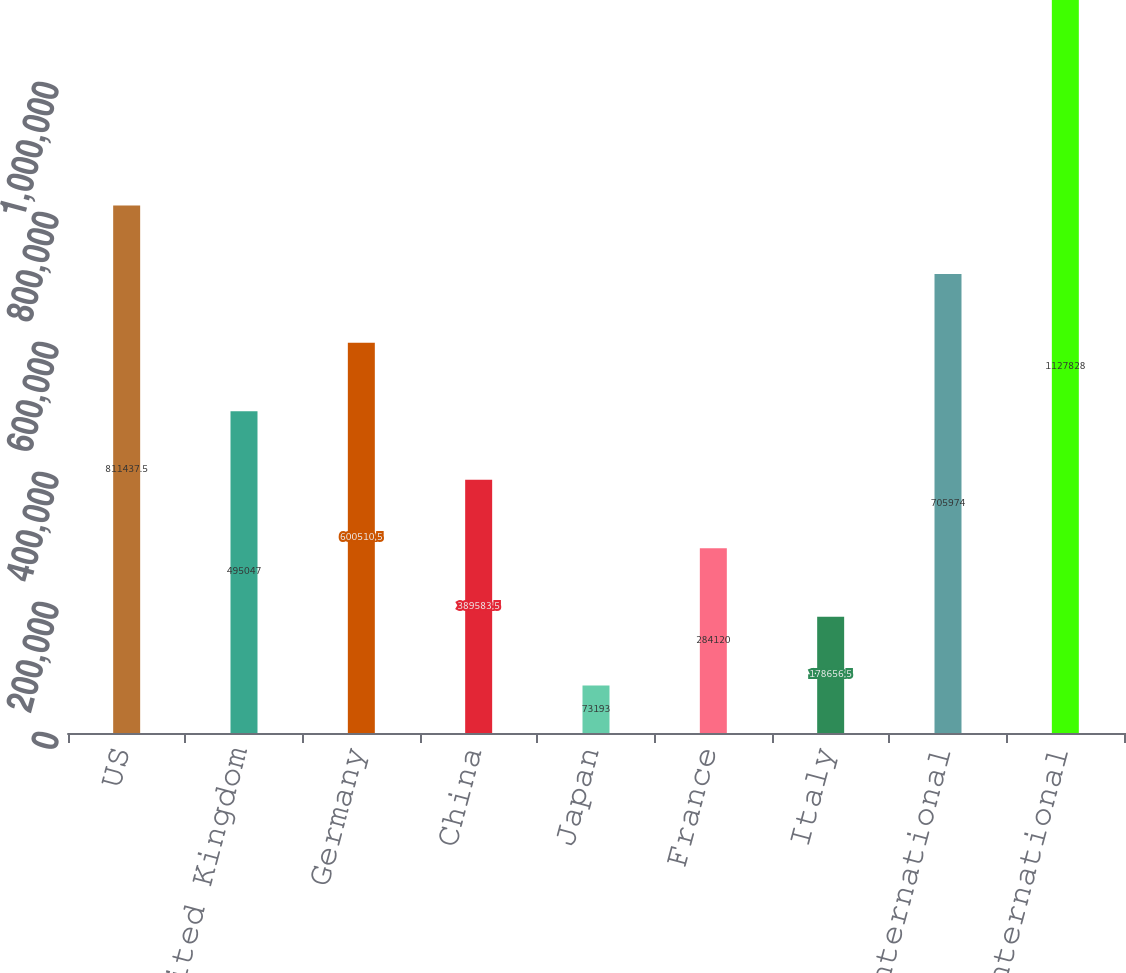Convert chart. <chart><loc_0><loc_0><loc_500><loc_500><bar_chart><fcel>US<fcel>United Kingdom<fcel>Germany<fcel>China<fcel>Japan<fcel>France<fcel>Italy<fcel>Other international<fcel>Total international<nl><fcel>811438<fcel>495047<fcel>600510<fcel>389584<fcel>73193<fcel>284120<fcel>178656<fcel>705974<fcel>1.12783e+06<nl></chart> 